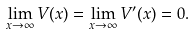<formula> <loc_0><loc_0><loc_500><loc_500>\lim _ { x \to \infty } V ( x ) = \lim _ { x \to \infty } V ^ { \prime } ( x ) = 0 .</formula> 